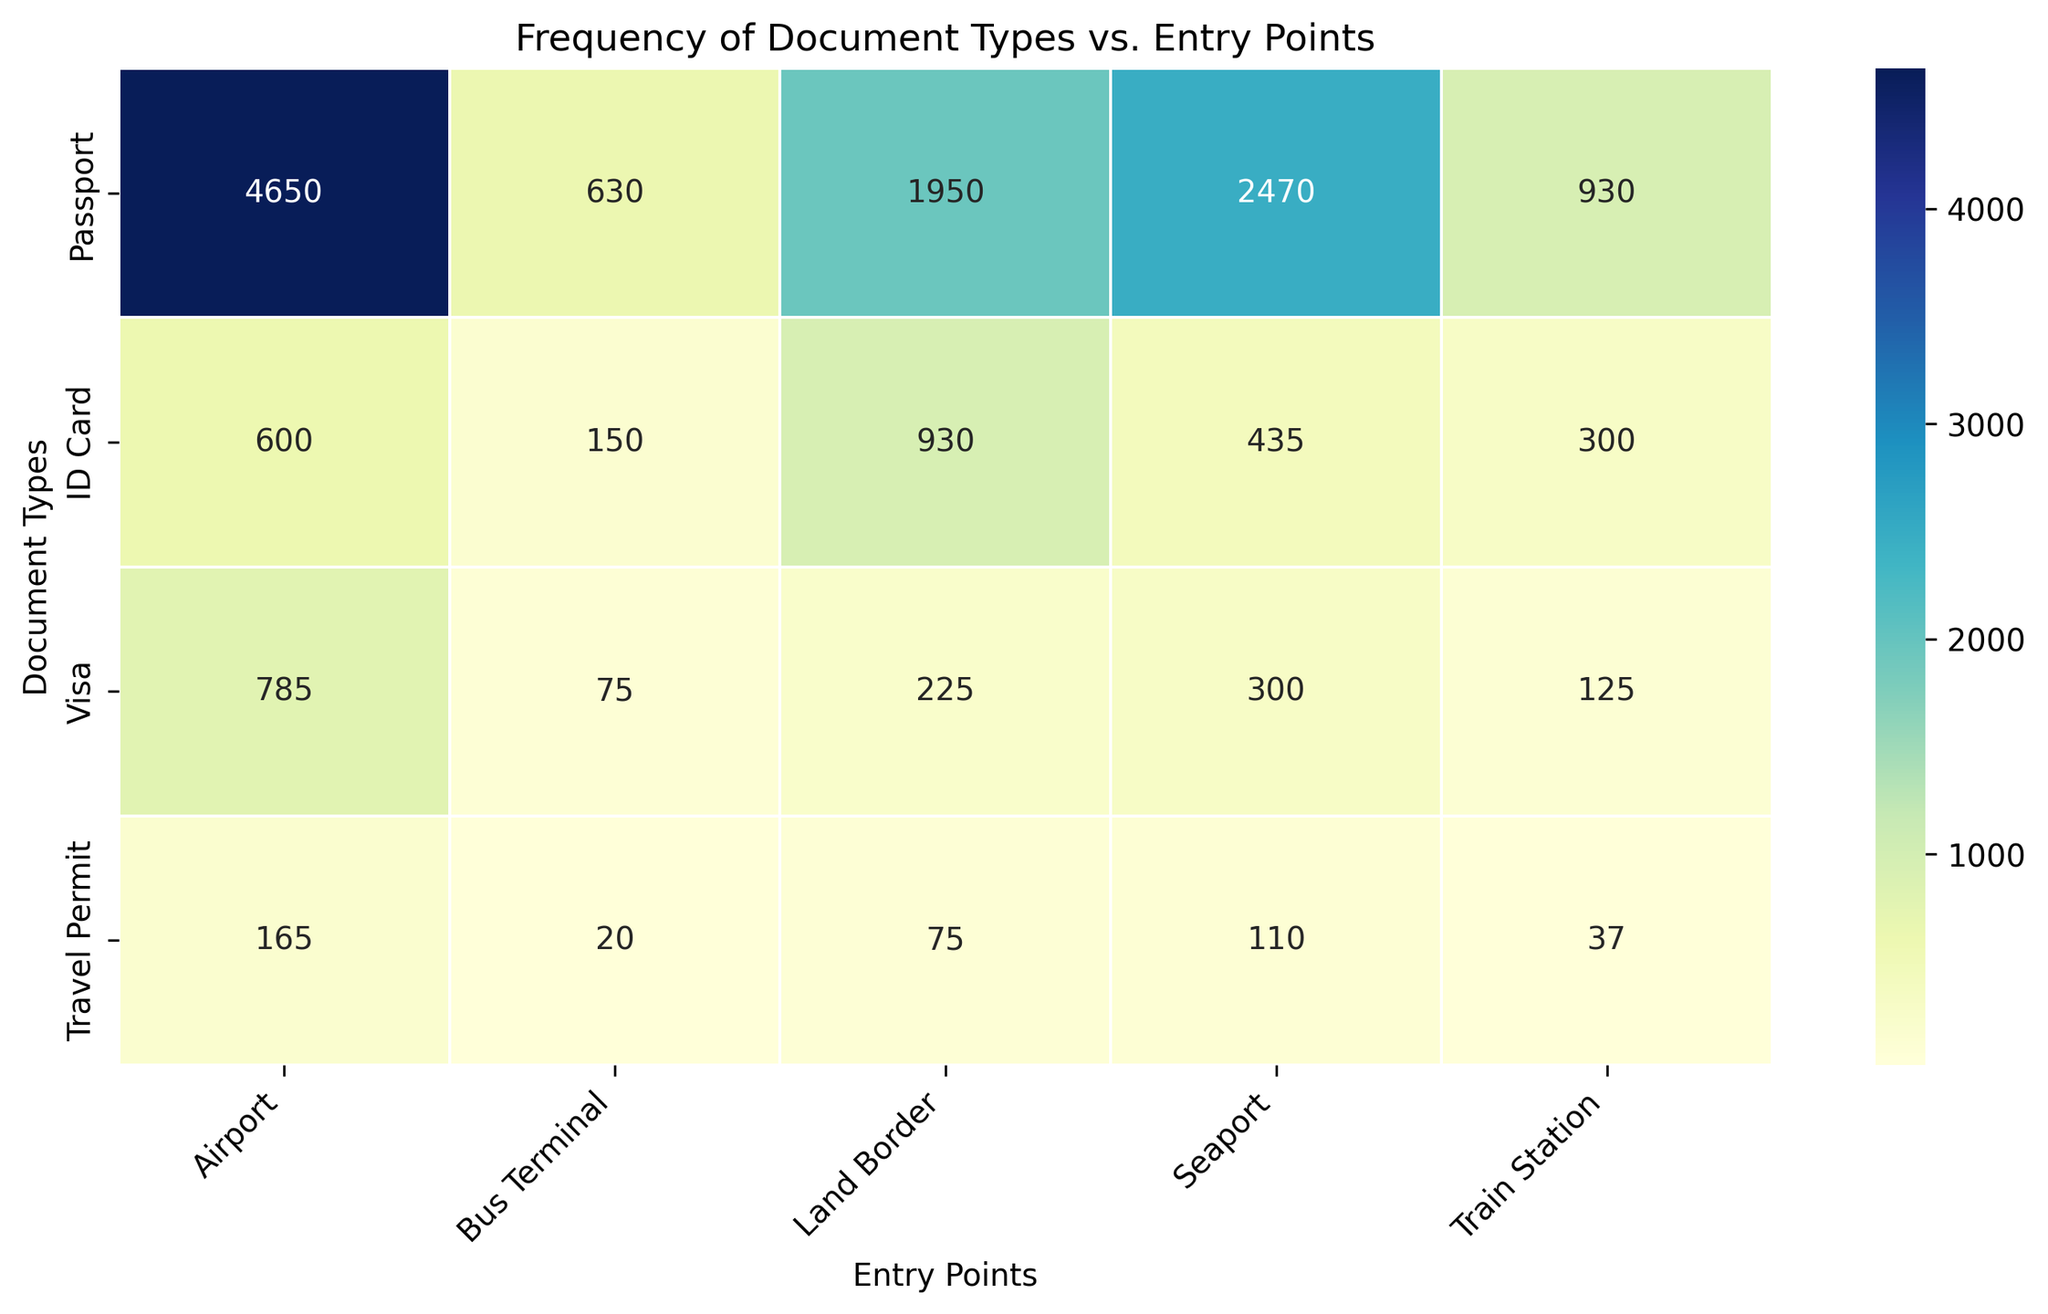Which entry point has the highest total number of document checks? To determine the entry point with the highest total number of document checks, sum the values for each document type (Passport, ID Card, Visa, Travel Permit) for each entry point and compare them. The airport has the highest values for all document types, indicating the highest total.
Answer: Airport Which document type is checked the most at seaports? Look at the values corresponding to each document type (Passport, ID Card, Visa, Travel Permit) for seaports. The highest value among these corresponds to the document type with the highest frequency.
Answer: Passport Are visas checked more frequently at land borders or bus terminals? Compare the number of visas checked at the land border and bus terminal by directly referring to the values in the respective row and column intersections. Land borders have consistently higher numbers for visas than bus terminals.
Answer: Land borders What is the total number of travel permits checked across all entry points? Sum the values for Travel Permits across all entry points: 50 + 40 + 25 + 10 + 5 + 55 + 35 + 30 + 15 + 10 + 60 + 35 + 20 + 12 + 5 = 402.
Answer: 402 Which entry point has a nearly equal number of passport and ID card checks? Compare the values of Passports and ID Cards for each entry point to find one where the numbers are close. The land border has 600 passports and 300 ID cards in one set and 700 passports and 310 ID cards in another, indicating values that are closer than other entry points.
Answer: Land border What is the average number of passports checked at airports? Sum the passport values for all rows corresponding to 'Airport' and divide by the number of these rows. (1500 + 1600 + 1550) / 3 = 4650 / 3 = 1550.
Answer: 1550 Which entry point has the lowest frequency of ID card checks? Identify the entry point with the smallest number in the column for ID Cards. The bus terminal has the lowest values across all sets of data.
Answer: Bus terminal How does the frequency of document checks at train stations compare to bus terminals for ID cards? Compare the frequency of ID Card checks at train stations with those at bus terminals by looking at the corresponding values. Train stations have higher values than bus terminals.
Answer: Train stations check more frequently What is the frequency difference for visas between seaports and airports? Calculate the difference for each set of values corresponding to visas at seaports and airports: 250 - 100 = 150, 275 - 110 = 165, and 260 - 90 = 170.
Answer: Differences are 150, 165, 170 Is the number of travel permits checked at train stations more than twice that at bus terminals? Double the travel permit values at bus terminals and compare them to those for train stations. For the first set, 10 compared to 5 × 2 = 10; second set, 15 compared to 10 × 2 = 20; third set, 12 compared to 5 × 2 = 10. Train stations have slightly higher values than twice bus terminals.
Answer: Yes 